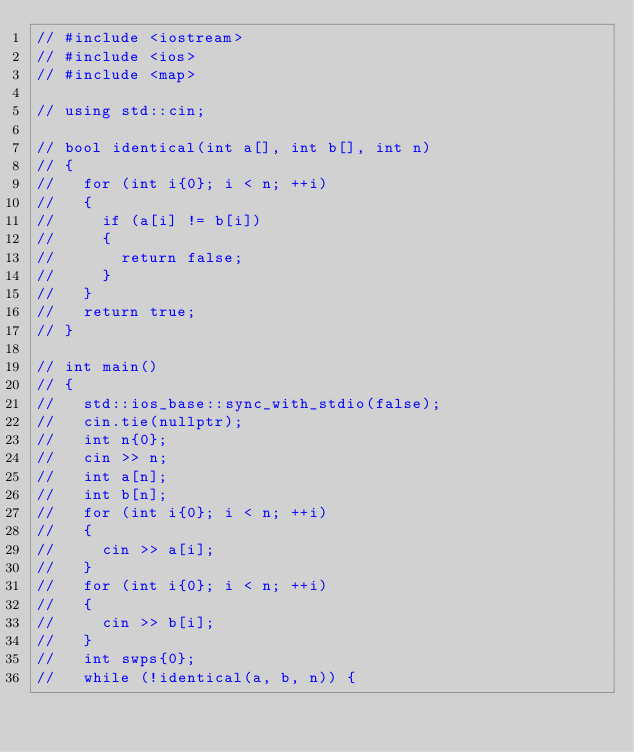Convert code to text. <code><loc_0><loc_0><loc_500><loc_500><_C++_>// #include <iostream>
// #include <ios>
// #include <map>

// using std::cin;

// bool identical(int a[], int b[], int n)
// {
//   for (int i{0}; i < n; ++i)
//   {
//     if (a[i] != b[i])
//     {
//       return false;
//     }
//   }
//   return true;
// }

// int main()
// {
//   std::ios_base::sync_with_stdio(false);
//   cin.tie(nullptr);
//   int n{0};
//   cin >> n;
//   int a[n];
//   int b[n];
//   for (int i{0}; i < n; ++i)
//   {
//     cin >> a[i];
//   }
//   for (int i{0}; i < n; ++i)
//   {
//     cin >> b[i];
//   }
//   int swps{0};
//   while (!identical(a, b, n)) {</code> 